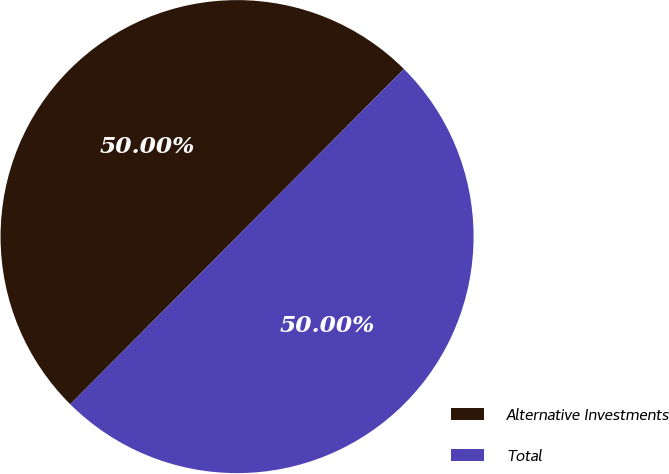Convert chart. <chart><loc_0><loc_0><loc_500><loc_500><pie_chart><fcel>Alternative Investments<fcel>Total<nl><fcel>50.0%<fcel>50.0%<nl></chart> 